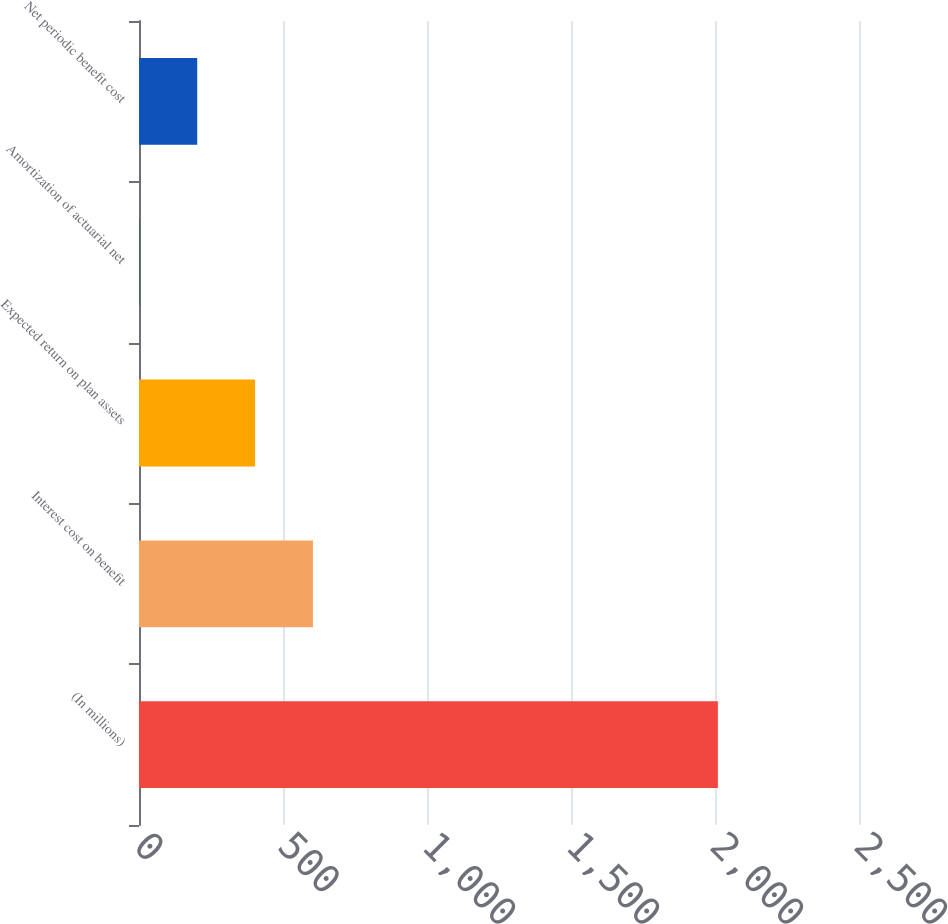Convert chart. <chart><loc_0><loc_0><loc_500><loc_500><bar_chart><fcel>(In millions)<fcel>Interest cost on benefit<fcel>Expected return on plan assets<fcel>Amortization of actuarial net<fcel>Net periodic benefit cost<nl><fcel>2010<fcel>603.91<fcel>403.04<fcel>1.3<fcel>202.17<nl></chart> 